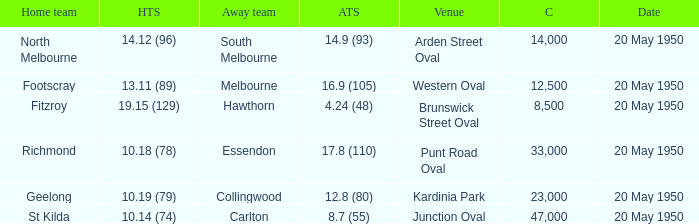Which team was the away team when the game was at punt road oval? Essendon. 